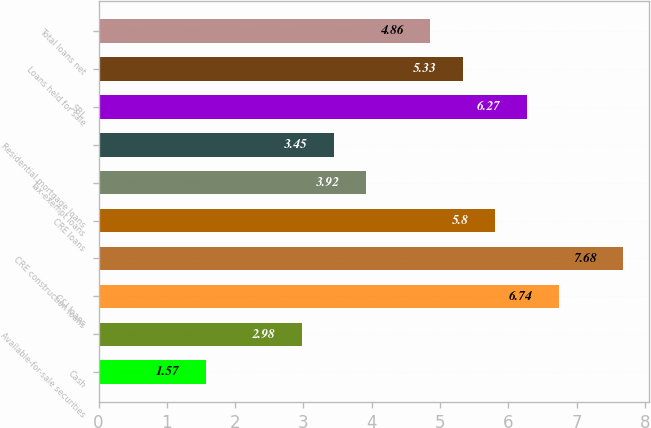Convert chart. <chart><loc_0><loc_0><loc_500><loc_500><bar_chart><fcel>Cash<fcel>Available-for-sale securities<fcel>C&I loans<fcel>CRE construction loans<fcel>CRE loans<fcel>Tax-exempt loans<fcel>Residential mortgage loans<fcel>SBL<fcel>Loans held for sale<fcel>Total loans net<nl><fcel>1.57<fcel>2.98<fcel>6.74<fcel>7.68<fcel>5.8<fcel>3.92<fcel>3.45<fcel>6.27<fcel>5.33<fcel>4.86<nl></chart> 